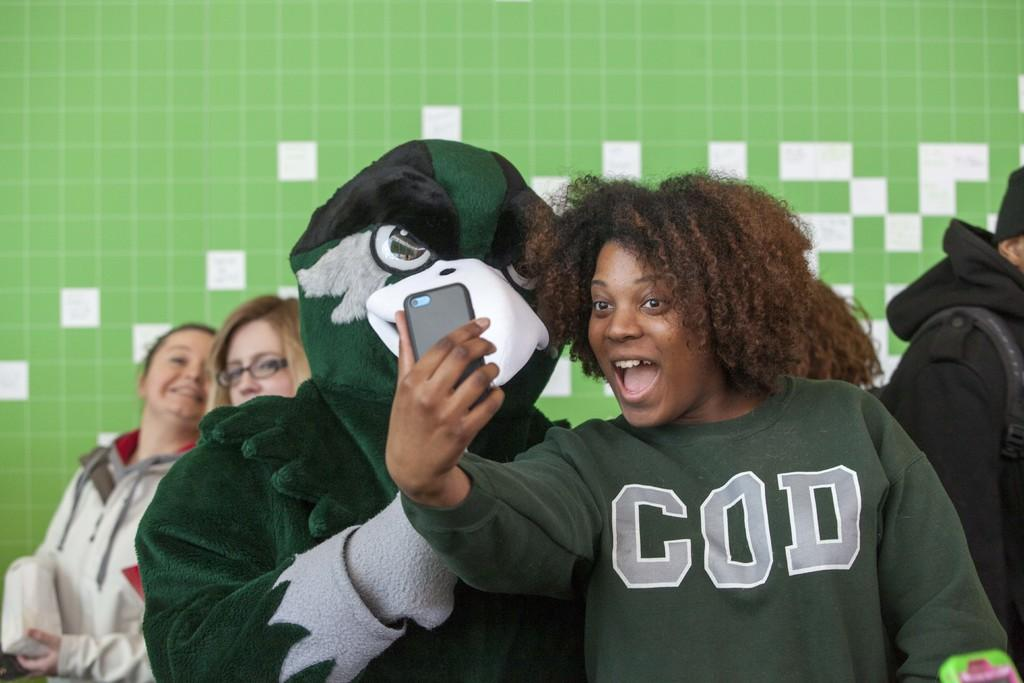What is happening between the two individuals in the image? The two individuals are standing beside each other, and both are taking a snap. What is the person on the left wearing? The person on the left is wearing a fancy dress. Can you describe the other individuals visible in the background of the image? There are other persons visible in the background of the image, but their clothing or actions are not specified in the provided facts. What type of flesh can be seen on the person's face in the image? There is no mention of flesh or any facial features in the provided facts, so it is not possible to answer this question. 